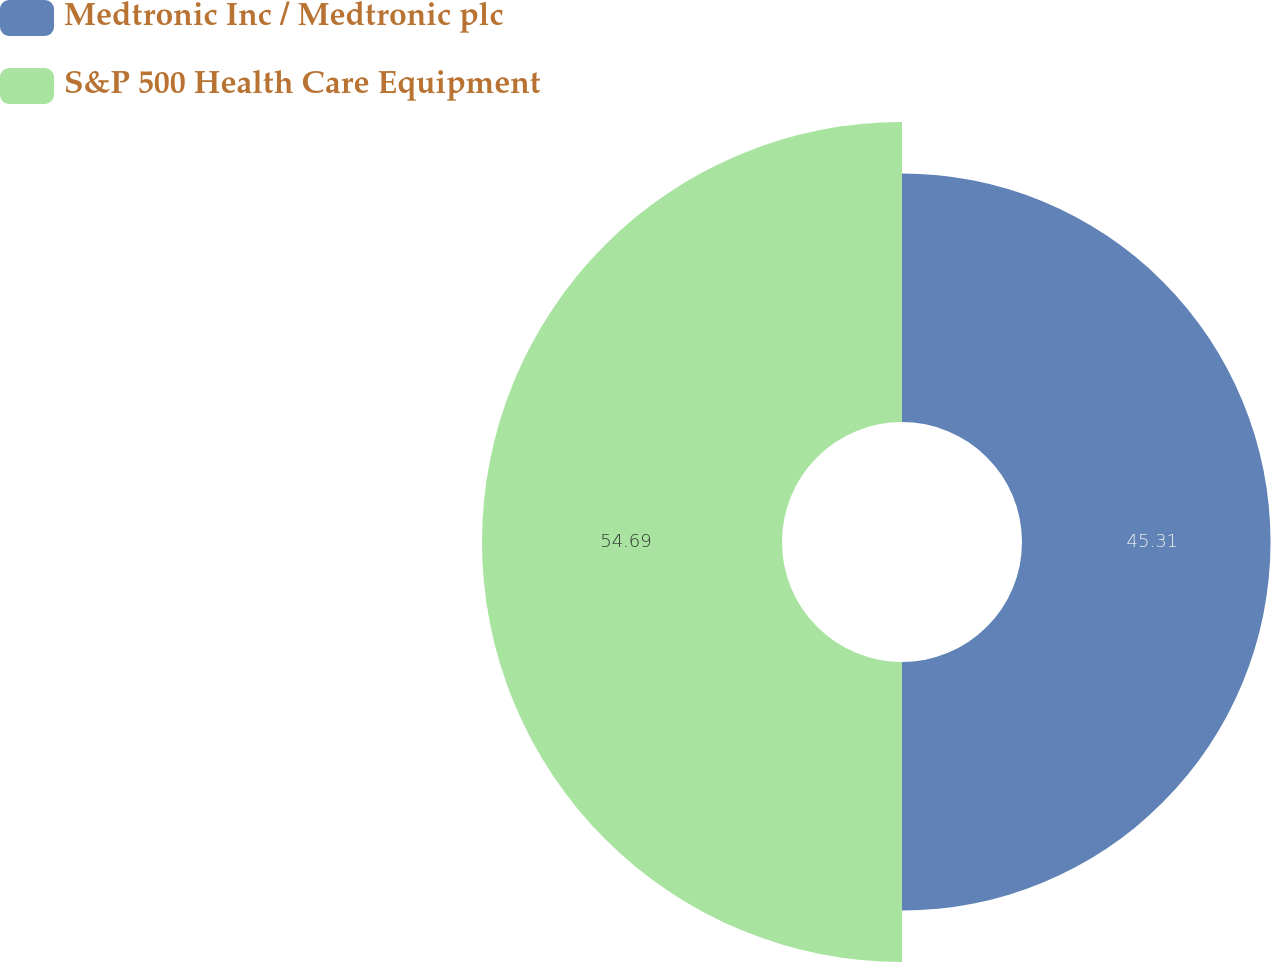<chart> <loc_0><loc_0><loc_500><loc_500><pie_chart><fcel>Medtronic Inc / Medtronic plc<fcel>S&P 500 Health Care Equipment<nl><fcel>45.31%<fcel>54.69%<nl></chart> 